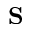Convert formula to latex. <formula><loc_0><loc_0><loc_500><loc_500>{ S }</formula> 